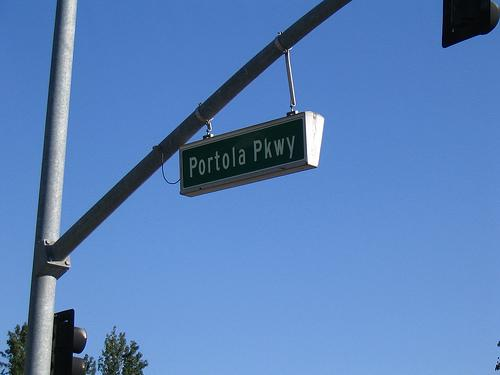Question: how many arms are holding the sign?
Choices:
A. 8.
B. 2.
C. 5.
D. 3.
Answer with the letter. Answer: B Question: what shape is the sign?
Choices:
A. An octogon.
B. A triangle.
C. A rectangle.
D. A circle.
Answer with the letter. Answer: C Question: what color is the pole?
Choices:
A. Blue.
B. Red.
C. Silver.
D. Gray.
Answer with the letter. Answer: D Question: what does the sign say?
Choices:
A. Stop.
B. Caution.
C. Roger's Highway.
D. Portola Pkwy.
Answer with the letter. Answer: D 